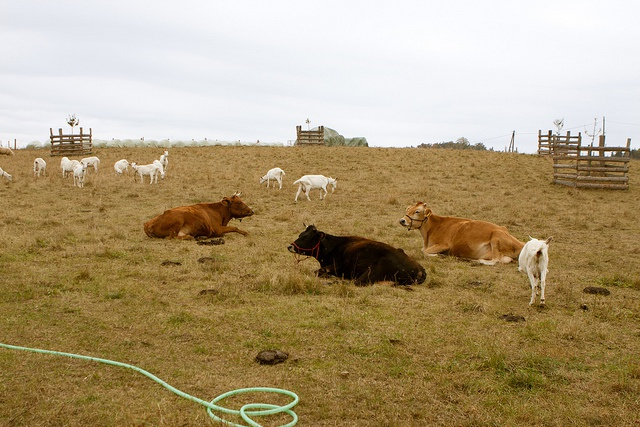Describe the objects in this image and their specific colors. I can see cow in white, black, maroon, and olive tones, cow in white, brown, maroon, and tan tones, cow in white, maroon, brown, and black tones, cow in white, lightgray, and tan tones, and cow in white, lightgray, and tan tones in this image. 